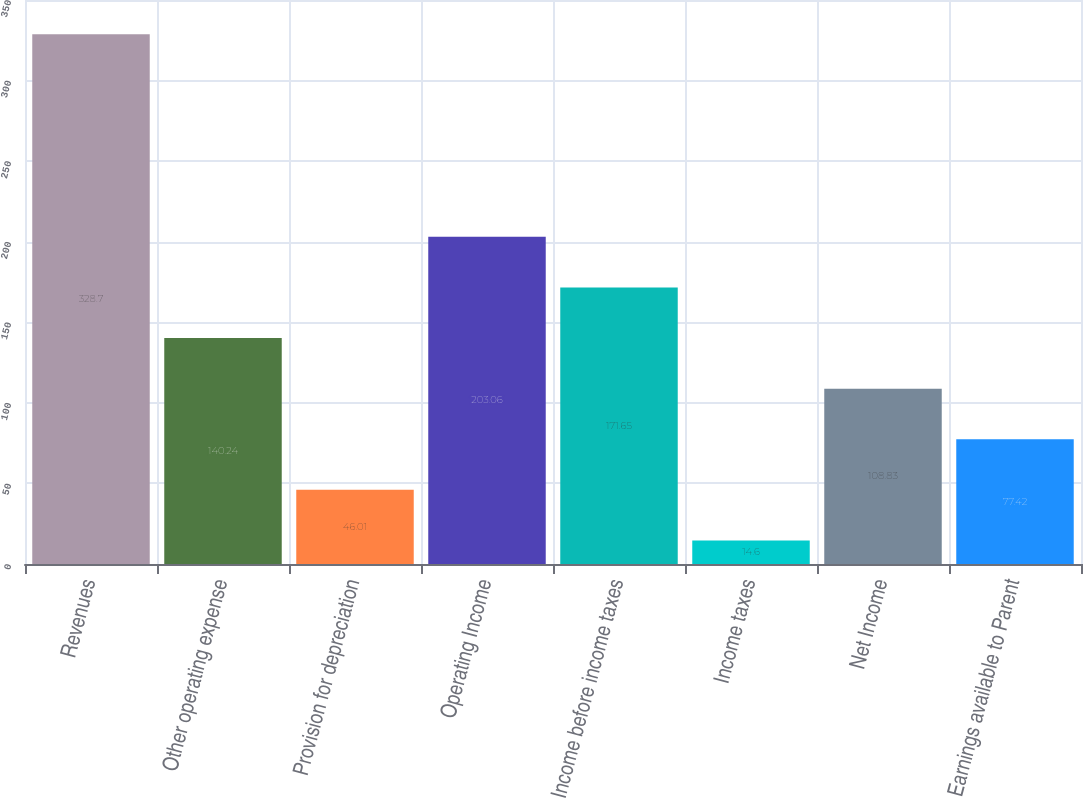Convert chart. <chart><loc_0><loc_0><loc_500><loc_500><bar_chart><fcel>Revenues<fcel>Other operating expense<fcel>Provision for depreciation<fcel>Operating Income<fcel>Income before income taxes<fcel>Income taxes<fcel>Net Income<fcel>Earnings available to Parent<nl><fcel>328.7<fcel>140.24<fcel>46.01<fcel>203.06<fcel>171.65<fcel>14.6<fcel>108.83<fcel>77.42<nl></chart> 